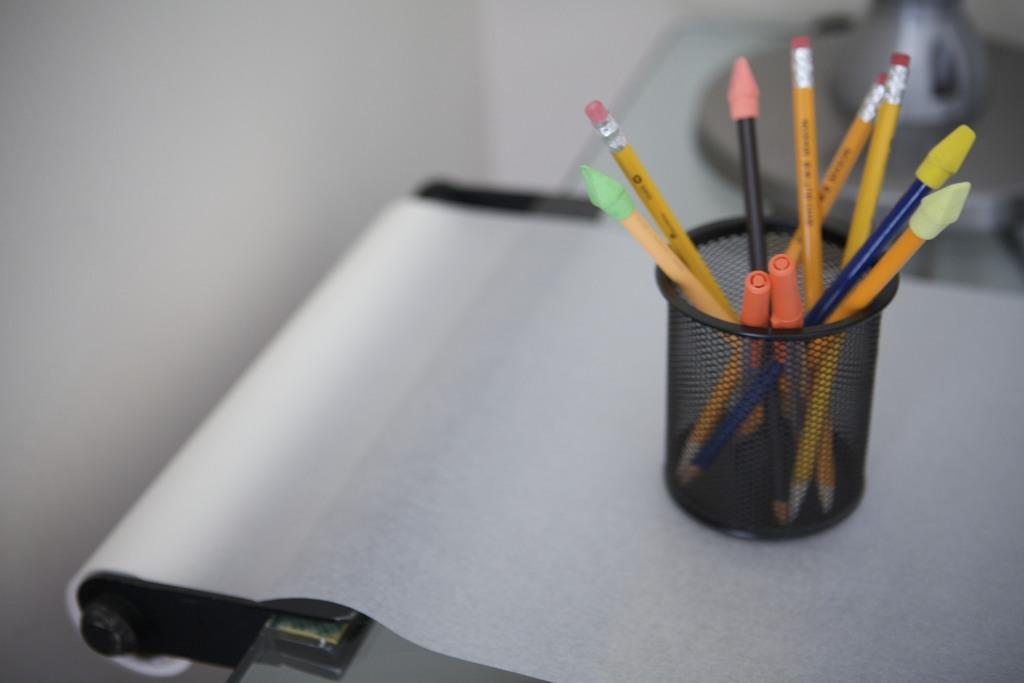What is present on the sheet of paper in the image? The facts provided do not specify any details about the sheet of paper. What is the pen holder used for? The pen holder is used for holding pens or other writing instruments. What other stationary items can be seen in the image? The facts provided do not specify any other stationary items in the image. Can you see a sea, bridge, or playground in the image? No, the image does not contain a sea, bridge, or playground. 